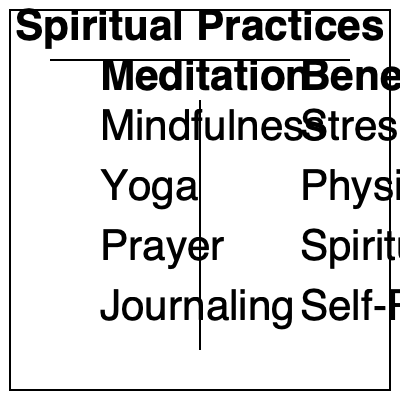Using the flowchart, match each spiritual practice to its primary benefit. Which practice is most directly associated with improving physical flexibility? To answer this question, we need to analyze the flowchart and match each spiritual practice to its corresponding benefit. Let's go through the process step-by-step:

1. Examine the left column of the flowchart, which lists spiritual practices:
   - Mindfulness
   - Yoga
   - Prayer
   - Journaling

2. Look at the right column, which lists benefits:
   - Stress Reduction
   - Physical Flexibility
   - Spiritual Connection
   - Self-Reflection

3. Match each practice to its most likely benefit:
   - Mindfulness is typically associated with Stress Reduction
   - Yoga is known for improving Physical Flexibility
   - Prayer is often linked to Spiritual Connection
   - Journaling is a tool for Self-Reflection

4. Identify the practice that is most directly associated with improving physical flexibility:
   Among the listed practices, Yoga is the one that focuses on physical postures and movements, making it the most directly associated with improving physical flexibility.

Therefore, the spiritual practice most directly associated with improving physical flexibility is Yoga.
Answer: Yoga 